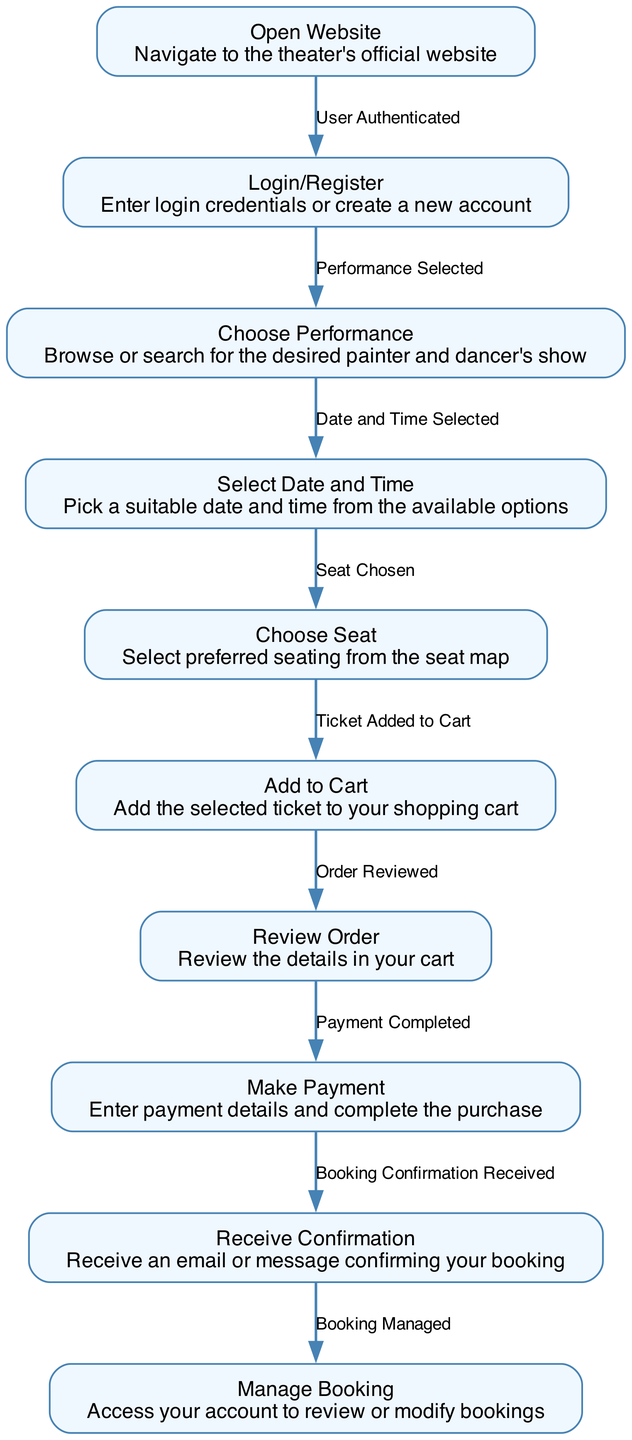What is the first step in the ticket booking process? The first step according to the flowchart is "Open Website," which involves navigating to the theater's official website to start the ticket booking process.
Answer: Open Website How many total steps are in the ticket booking flowchart? By counting each distinct step listed in the flowchart, we find that there are 10 total steps from "Open Website" to "Manage Booking."
Answer: 10 What action follows 'Choose Seat'? The action that follows 'Choose Seat' is 'Add to Cart,' which means the selected ticket is added to the shopping cart for the purchasing process.
Answer: Add to Cart What is the output after making a payment? The output after making a payment is 'Payment Completed,' signifying that the transaction has been successfully processed for the ticket purchase.
Answer: Payment Completed Which step allows the user to customize their experience by selecting date and time? The step that allows customization through selecting a date and time is 'Select Date and Time.' This step empowers the user to choose a date and time that suits them.
Answer: Select Date and Time What action is taken to ensure that the performance details are correct before proceeding to payment? The action taken to ensure the performance details are correct is 'Review Order,' where the user reviews the order details in their cart before finalizing the purchase.
Answer: Review Order What is the final action in the diagram? The final action in the diagram is 'Manage Booking,' which allows users to access their account to oversee or change their bookings as needed.
Answer: Manage Booking What is the output when 'Login/Register' is successfully completed? The output when 'Login/Register' is successfully completed is 'User Authenticated,' indicating that the user has successfully logged into their account or created a new one.
Answer: User Authenticated What step directly follows 'Choose Performance'? The step that directly follows 'Choose Performance' is 'Select Date and Time,' indicating that after selecting a performance, the user is prompted to choose when they want to attend it.
Answer: Select Date and Time 